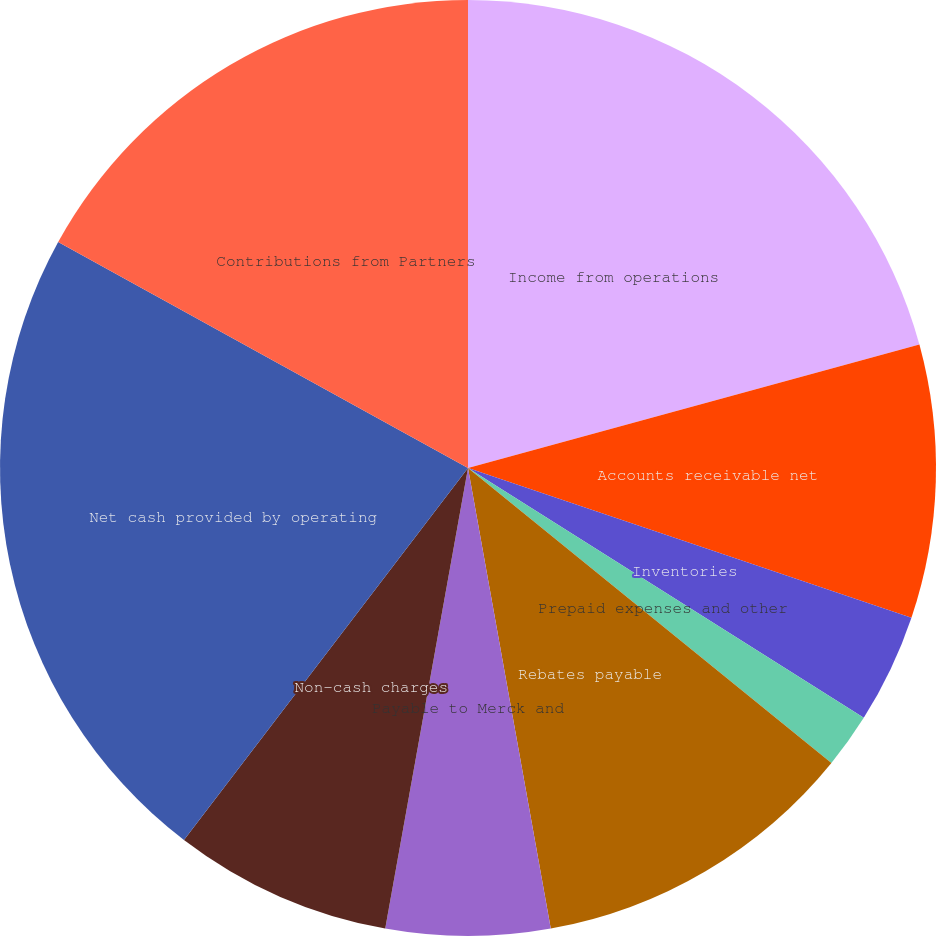Convert chart. <chart><loc_0><loc_0><loc_500><loc_500><pie_chart><fcel>Income from operations<fcel>Accounts receivable net<fcel>Inventories<fcel>Prepaid expenses and other<fcel>Rebates payable<fcel>Payable to Merck and<fcel>Accrued expenses and other<fcel>Non-cash charges<fcel>Net cash provided by operating<fcel>Contributions from Partners<nl><fcel>20.75%<fcel>9.43%<fcel>3.78%<fcel>1.89%<fcel>11.32%<fcel>5.66%<fcel>0.0%<fcel>7.55%<fcel>22.64%<fcel>16.98%<nl></chart> 